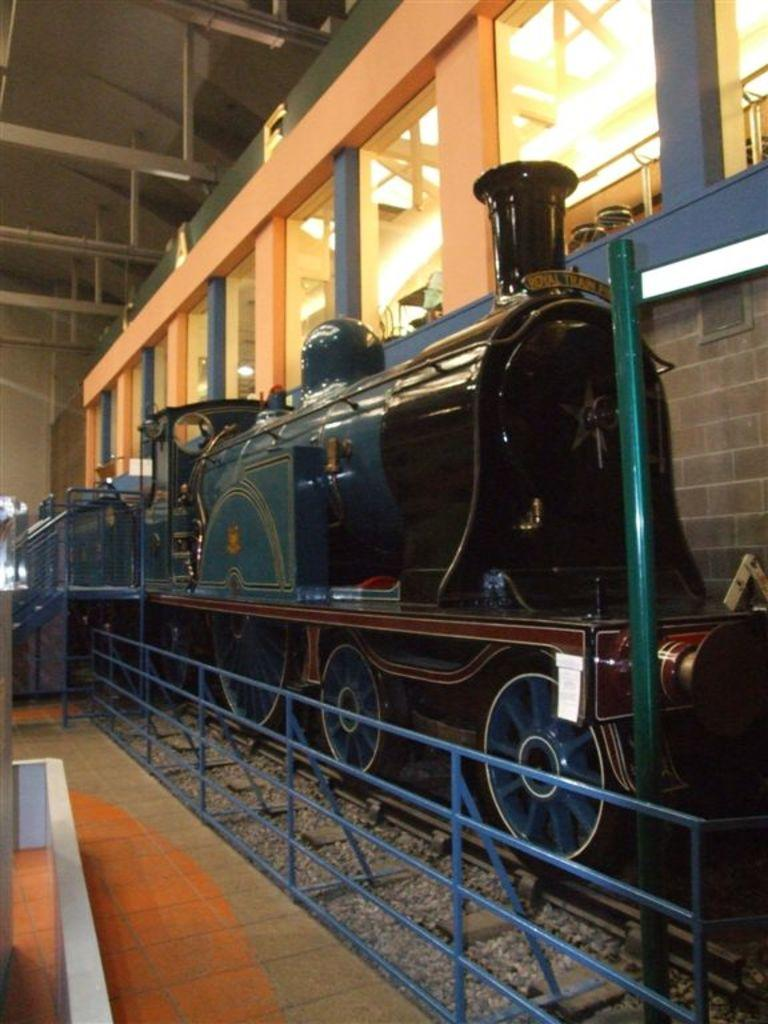What is the main subject of the image? The main subject of the image is a train on the track. What can be seen near the train in the image? There is a fence in the image. What is visible in the background of the image? There is a wall, windows, and a rooftop in the background of the image. Can you describe the setting of the image? The image may have been taken in a factory setting. What type of yam is being used to hold the attention of the train in the image? There is no yam present in the image, and the train is not holding anyone's attention. How many forks can be seen in the image? There are no forks present in the image. 